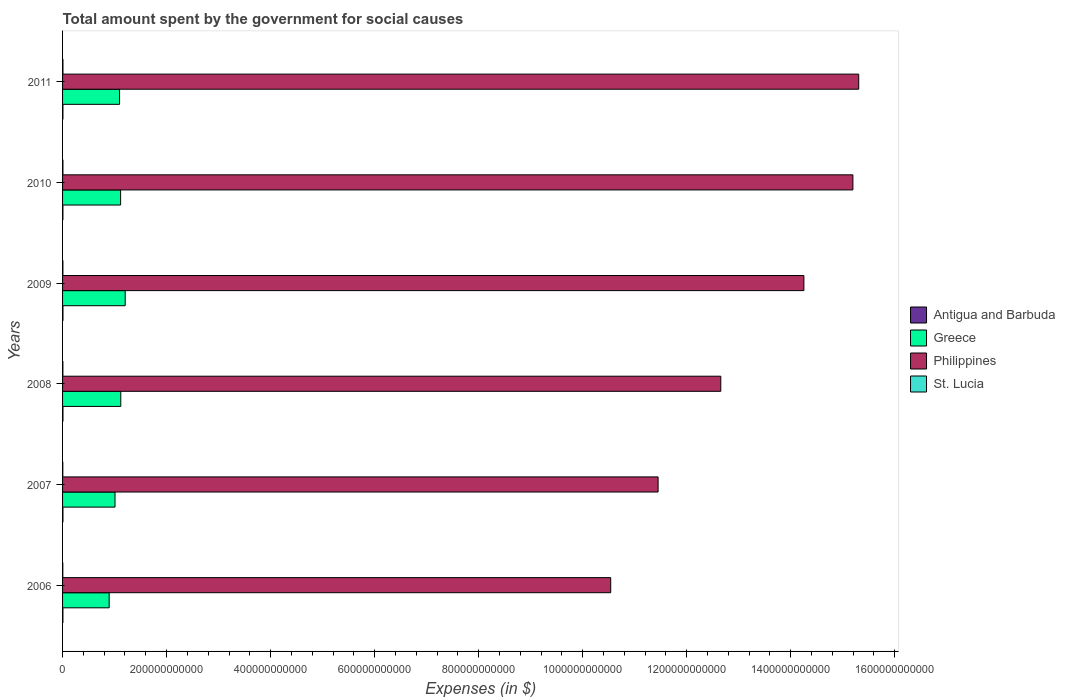How many groups of bars are there?
Ensure brevity in your answer.  6. Are the number of bars per tick equal to the number of legend labels?
Ensure brevity in your answer.  Yes. How many bars are there on the 4th tick from the bottom?
Give a very brief answer. 4. What is the label of the 4th group of bars from the top?
Offer a terse response. 2008. What is the amount spent for social causes by the government in Antigua and Barbuda in 2009?
Your response must be concise. 7.82e+08. Across all years, what is the maximum amount spent for social causes by the government in Greece?
Offer a terse response. 1.20e+11. Across all years, what is the minimum amount spent for social causes by the government in Greece?
Offer a very short reply. 8.96e+1. In which year was the amount spent for social causes by the government in Antigua and Barbuda maximum?
Ensure brevity in your answer.  2009. What is the total amount spent for social causes by the government in Antigua and Barbuda in the graph?
Provide a succinct answer. 4.37e+09. What is the difference between the amount spent for social causes by the government in St. Lucia in 2010 and that in 2011?
Your answer should be compact. -2.20e+07. What is the difference between the amount spent for social causes by the government in Greece in 2006 and the amount spent for social causes by the government in St. Lucia in 2008?
Keep it short and to the point. 8.89e+1. What is the average amount spent for social causes by the government in Greece per year?
Give a very brief answer. 1.07e+11. In the year 2006, what is the difference between the amount spent for social causes by the government in Philippines and amount spent for social causes by the government in St. Lucia?
Give a very brief answer. 1.05e+12. What is the ratio of the amount spent for social causes by the government in Philippines in 2008 to that in 2011?
Your answer should be very brief. 0.83. Is the amount spent for social causes by the government in Antigua and Barbuda in 2009 less than that in 2010?
Ensure brevity in your answer.  No. What is the difference between the highest and the second highest amount spent for social causes by the government in Greece?
Your answer should be compact. 8.50e+09. What is the difference between the highest and the lowest amount spent for social causes by the government in Greece?
Ensure brevity in your answer.  3.09e+1. In how many years, is the amount spent for social causes by the government in Greece greater than the average amount spent for social causes by the government in Greece taken over all years?
Offer a very short reply. 4. Is the sum of the amount spent for social causes by the government in Greece in 2006 and 2011 greater than the maximum amount spent for social causes by the government in Antigua and Barbuda across all years?
Provide a succinct answer. Yes. Is it the case that in every year, the sum of the amount spent for social causes by the government in St. Lucia and amount spent for social causes by the government in Antigua and Barbuda is greater than the sum of amount spent for social causes by the government in Greece and amount spent for social causes by the government in Philippines?
Your answer should be very brief. No. What does the 3rd bar from the top in 2011 represents?
Ensure brevity in your answer.  Greece. Is it the case that in every year, the sum of the amount spent for social causes by the government in St. Lucia and amount spent for social causes by the government in Philippines is greater than the amount spent for social causes by the government in Greece?
Offer a very short reply. Yes. How many years are there in the graph?
Your answer should be very brief. 6. What is the difference between two consecutive major ticks on the X-axis?
Your response must be concise. 2.00e+11. Does the graph contain any zero values?
Offer a terse response. No. How many legend labels are there?
Your response must be concise. 4. How are the legend labels stacked?
Offer a very short reply. Vertical. What is the title of the graph?
Your answer should be compact. Total amount spent by the government for social causes. What is the label or title of the X-axis?
Your answer should be very brief. Expenses (in $). What is the label or title of the Y-axis?
Give a very brief answer. Years. What is the Expenses (in $) in Antigua and Barbuda in 2006?
Give a very brief answer. 6.84e+08. What is the Expenses (in $) of Greece in 2006?
Keep it short and to the point. 8.96e+1. What is the Expenses (in $) of Philippines in 2006?
Give a very brief answer. 1.05e+12. What is the Expenses (in $) of St. Lucia in 2006?
Give a very brief answer. 4.85e+08. What is the Expenses (in $) in Antigua and Barbuda in 2007?
Make the answer very short. 7.50e+08. What is the Expenses (in $) in Greece in 2007?
Provide a short and direct response. 1.01e+11. What is the Expenses (in $) in Philippines in 2007?
Offer a terse response. 1.15e+12. What is the Expenses (in $) of St. Lucia in 2007?
Make the answer very short. 4.82e+08. What is the Expenses (in $) in Antigua and Barbuda in 2008?
Ensure brevity in your answer.  7.66e+08. What is the Expenses (in $) in Greece in 2008?
Offer a very short reply. 1.12e+11. What is the Expenses (in $) in Philippines in 2008?
Make the answer very short. 1.27e+12. What is the Expenses (in $) in St. Lucia in 2008?
Offer a terse response. 6.27e+08. What is the Expenses (in $) in Antigua and Barbuda in 2009?
Your answer should be compact. 7.82e+08. What is the Expenses (in $) of Greece in 2009?
Provide a succinct answer. 1.20e+11. What is the Expenses (in $) of Philippines in 2009?
Ensure brevity in your answer.  1.43e+12. What is the Expenses (in $) of St. Lucia in 2009?
Provide a short and direct response. 6.62e+08. What is the Expenses (in $) of Antigua and Barbuda in 2010?
Provide a succinct answer. 6.76e+08. What is the Expenses (in $) of Greece in 2010?
Keep it short and to the point. 1.12e+11. What is the Expenses (in $) of Philippines in 2010?
Give a very brief answer. 1.52e+12. What is the Expenses (in $) of St. Lucia in 2010?
Your answer should be compact. 7.23e+08. What is the Expenses (in $) in Antigua and Barbuda in 2011?
Your response must be concise. 7.15e+08. What is the Expenses (in $) of Greece in 2011?
Provide a short and direct response. 1.10e+11. What is the Expenses (in $) of Philippines in 2011?
Make the answer very short. 1.53e+12. What is the Expenses (in $) in St. Lucia in 2011?
Give a very brief answer. 7.45e+08. Across all years, what is the maximum Expenses (in $) of Antigua and Barbuda?
Provide a short and direct response. 7.82e+08. Across all years, what is the maximum Expenses (in $) in Greece?
Give a very brief answer. 1.20e+11. Across all years, what is the maximum Expenses (in $) of Philippines?
Your answer should be compact. 1.53e+12. Across all years, what is the maximum Expenses (in $) of St. Lucia?
Ensure brevity in your answer.  7.45e+08. Across all years, what is the minimum Expenses (in $) of Antigua and Barbuda?
Offer a very short reply. 6.76e+08. Across all years, what is the minimum Expenses (in $) in Greece?
Provide a short and direct response. 8.96e+1. Across all years, what is the minimum Expenses (in $) of Philippines?
Make the answer very short. 1.05e+12. Across all years, what is the minimum Expenses (in $) of St. Lucia?
Ensure brevity in your answer.  4.82e+08. What is the total Expenses (in $) in Antigua and Barbuda in the graph?
Your response must be concise. 4.37e+09. What is the total Expenses (in $) of Greece in the graph?
Give a very brief answer. 6.44e+11. What is the total Expenses (in $) of Philippines in the graph?
Provide a succinct answer. 7.94e+12. What is the total Expenses (in $) of St. Lucia in the graph?
Your answer should be compact. 3.72e+09. What is the difference between the Expenses (in $) in Antigua and Barbuda in 2006 and that in 2007?
Your answer should be compact. -6.55e+07. What is the difference between the Expenses (in $) of Greece in 2006 and that in 2007?
Your answer should be compact. -1.13e+1. What is the difference between the Expenses (in $) in Philippines in 2006 and that in 2007?
Provide a succinct answer. -9.11e+1. What is the difference between the Expenses (in $) in St. Lucia in 2006 and that in 2007?
Provide a succinct answer. 2.40e+06. What is the difference between the Expenses (in $) in Antigua and Barbuda in 2006 and that in 2008?
Make the answer very short. -8.22e+07. What is the difference between the Expenses (in $) of Greece in 2006 and that in 2008?
Your response must be concise. -2.24e+1. What is the difference between the Expenses (in $) in Philippines in 2006 and that in 2008?
Make the answer very short. -2.12e+11. What is the difference between the Expenses (in $) of St. Lucia in 2006 and that in 2008?
Offer a terse response. -1.43e+08. What is the difference between the Expenses (in $) of Antigua and Barbuda in 2006 and that in 2009?
Give a very brief answer. -9.76e+07. What is the difference between the Expenses (in $) in Greece in 2006 and that in 2009?
Offer a terse response. -3.09e+1. What is the difference between the Expenses (in $) of Philippines in 2006 and that in 2009?
Your response must be concise. -3.71e+11. What is the difference between the Expenses (in $) of St. Lucia in 2006 and that in 2009?
Give a very brief answer. -1.77e+08. What is the difference between the Expenses (in $) in Antigua and Barbuda in 2006 and that in 2010?
Ensure brevity in your answer.  7.90e+06. What is the difference between the Expenses (in $) in Greece in 2006 and that in 2010?
Offer a very short reply. -2.20e+1. What is the difference between the Expenses (in $) of Philippines in 2006 and that in 2010?
Give a very brief answer. -4.66e+11. What is the difference between the Expenses (in $) of St. Lucia in 2006 and that in 2010?
Keep it short and to the point. -2.38e+08. What is the difference between the Expenses (in $) in Antigua and Barbuda in 2006 and that in 2011?
Make the answer very short. -3.06e+07. What is the difference between the Expenses (in $) of Greece in 2006 and that in 2011?
Offer a very short reply. -2.00e+1. What is the difference between the Expenses (in $) of Philippines in 2006 and that in 2011?
Your answer should be compact. -4.77e+11. What is the difference between the Expenses (in $) of St. Lucia in 2006 and that in 2011?
Ensure brevity in your answer.  -2.60e+08. What is the difference between the Expenses (in $) in Antigua and Barbuda in 2007 and that in 2008?
Keep it short and to the point. -1.67e+07. What is the difference between the Expenses (in $) of Greece in 2007 and that in 2008?
Ensure brevity in your answer.  -1.11e+1. What is the difference between the Expenses (in $) in Philippines in 2007 and that in 2008?
Offer a terse response. -1.21e+11. What is the difference between the Expenses (in $) in St. Lucia in 2007 and that in 2008?
Make the answer very short. -1.45e+08. What is the difference between the Expenses (in $) in Antigua and Barbuda in 2007 and that in 2009?
Provide a short and direct response. -3.21e+07. What is the difference between the Expenses (in $) in Greece in 2007 and that in 2009?
Your response must be concise. -1.96e+1. What is the difference between the Expenses (in $) of Philippines in 2007 and that in 2009?
Your answer should be very brief. -2.80e+11. What is the difference between the Expenses (in $) in St. Lucia in 2007 and that in 2009?
Your answer should be compact. -1.79e+08. What is the difference between the Expenses (in $) in Antigua and Barbuda in 2007 and that in 2010?
Ensure brevity in your answer.  7.34e+07. What is the difference between the Expenses (in $) in Greece in 2007 and that in 2010?
Ensure brevity in your answer.  -1.08e+1. What is the difference between the Expenses (in $) of Philippines in 2007 and that in 2010?
Ensure brevity in your answer.  -3.75e+11. What is the difference between the Expenses (in $) of St. Lucia in 2007 and that in 2010?
Provide a succinct answer. -2.41e+08. What is the difference between the Expenses (in $) in Antigua and Barbuda in 2007 and that in 2011?
Give a very brief answer. 3.49e+07. What is the difference between the Expenses (in $) of Greece in 2007 and that in 2011?
Offer a very short reply. -8.78e+09. What is the difference between the Expenses (in $) in Philippines in 2007 and that in 2011?
Give a very brief answer. -3.86e+11. What is the difference between the Expenses (in $) in St. Lucia in 2007 and that in 2011?
Give a very brief answer. -2.63e+08. What is the difference between the Expenses (in $) of Antigua and Barbuda in 2008 and that in 2009?
Provide a short and direct response. -1.54e+07. What is the difference between the Expenses (in $) of Greece in 2008 and that in 2009?
Your answer should be very brief. -8.50e+09. What is the difference between the Expenses (in $) in Philippines in 2008 and that in 2009?
Your response must be concise. -1.60e+11. What is the difference between the Expenses (in $) of St. Lucia in 2008 and that in 2009?
Provide a short and direct response. -3.44e+07. What is the difference between the Expenses (in $) in Antigua and Barbuda in 2008 and that in 2010?
Provide a short and direct response. 9.01e+07. What is the difference between the Expenses (in $) in Greece in 2008 and that in 2010?
Ensure brevity in your answer.  3.37e+08. What is the difference between the Expenses (in $) in Philippines in 2008 and that in 2010?
Offer a terse response. -2.54e+11. What is the difference between the Expenses (in $) of St. Lucia in 2008 and that in 2010?
Provide a succinct answer. -9.58e+07. What is the difference between the Expenses (in $) of Antigua and Barbuda in 2008 and that in 2011?
Your answer should be very brief. 5.16e+07. What is the difference between the Expenses (in $) of Greece in 2008 and that in 2011?
Provide a short and direct response. 2.32e+09. What is the difference between the Expenses (in $) of Philippines in 2008 and that in 2011?
Offer a terse response. -2.65e+11. What is the difference between the Expenses (in $) of St. Lucia in 2008 and that in 2011?
Keep it short and to the point. -1.18e+08. What is the difference between the Expenses (in $) in Antigua and Barbuda in 2009 and that in 2010?
Your answer should be very brief. 1.06e+08. What is the difference between the Expenses (in $) in Greece in 2009 and that in 2010?
Offer a terse response. 8.84e+09. What is the difference between the Expenses (in $) of Philippines in 2009 and that in 2010?
Give a very brief answer. -9.42e+1. What is the difference between the Expenses (in $) of St. Lucia in 2009 and that in 2010?
Offer a terse response. -6.14e+07. What is the difference between the Expenses (in $) of Antigua and Barbuda in 2009 and that in 2011?
Your answer should be compact. 6.70e+07. What is the difference between the Expenses (in $) of Greece in 2009 and that in 2011?
Make the answer very short. 1.08e+1. What is the difference between the Expenses (in $) of Philippines in 2009 and that in 2011?
Provide a succinct answer. -1.05e+11. What is the difference between the Expenses (in $) in St. Lucia in 2009 and that in 2011?
Make the answer very short. -8.34e+07. What is the difference between the Expenses (in $) of Antigua and Barbuda in 2010 and that in 2011?
Keep it short and to the point. -3.85e+07. What is the difference between the Expenses (in $) of Greece in 2010 and that in 2011?
Offer a very short reply. 1.98e+09. What is the difference between the Expenses (in $) of Philippines in 2010 and that in 2011?
Your response must be concise. -1.12e+1. What is the difference between the Expenses (in $) in St. Lucia in 2010 and that in 2011?
Your response must be concise. -2.20e+07. What is the difference between the Expenses (in $) of Antigua and Barbuda in 2006 and the Expenses (in $) of Greece in 2007?
Make the answer very short. -1.00e+11. What is the difference between the Expenses (in $) in Antigua and Barbuda in 2006 and the Expenses (in $) in Philippines in 2007?
Keep it short and to the point. -1.14e+12. What is the difference between the Expenses (in $) of Antigua and Barbuda in 2006 and the Expenses (in $) of St. Lucia in 2007?
Provide a short and direct response. 2.02e+08. What is the difference between the Expenses (in $) in Greece in 2006 and the Expenses (in $) in Philippines in 2007?
Ensure brevity in your answer.  -1.06e+12. What is the difference between the Expenses (in $) in Greece in 2006 and the Expenses (in $) in St. Lucia in 2007?
Give a very brief answer. 8.91e+1. What is the difference between the Expenses (in $) in Philippines in 2006 and the Expenses (in $) in St. Lucia in 2007?
Your answer should be compact. 1.05e+12. What is the difference between the Expenses (in $) in Antigua and Barbuda in 2006 and the Expenses (in $) in Greece in 2008?
Keep it short and to the point. -1.11e+11. What is the difference between the Expenses (in $) in Antigua and Barbuda in 2006 and the Expenses (in $) in Philippines in 2008?
Make the answer very short. -1.26e+12. What is the difference between the Expenses (in $) of Antigua and Barbuda in 2006 and the Expenses (in $) of St. Lucia in 2008?
Your answer should be compact. 5.67e+07. What is the difference between the Expenses (in $) of Greece in 2006 and the Expenses (in $) of Philippines in 2008?
Your response must be concise. -1.18e+12. What is the difference between the Expenses (in $) in Greece in 2006 and the Expenses (in $) in St. Lucia in 2008?
Your answer should be very brief. 8.89e+1. What is the difference between the Expenses (in $) of Philippines in 2006 and the Expenses (in $) of St. Lucia in 2008?
Give a very brief answer. 1.05e+12. What is the difference between the Expenses (in $) in Antigua and Barbuda in 2006 and the Expenses (in $) in Greece in 2009?
Give a very brief answer. -1.20e+11. What is the difference between the Expenses (in $) in Antigua and Barbuda in 2006 and the Expenses (in $) in Philippines in 2009?
Make the answer very short. -1.42e+12. What is the difference between the Expenses (in $) of Antigua and Barbuda in 2006 and the Expenses (in $) of St. Lucia in 2009?
Provide a succinct answer. 2.23e+07. What is the difference between the Expenses (in $) of Greece in 2006 and the Expenses (in $) of Philippines in 2009?
Ensure brevity in your answer.  -1.34e+12. What is the difference between the Expenses (in $) in Greece in 2006 and the Expenses (in $) in St. Lucia in 2009?
Offer a terse response. 8.89e+1. What is the difference between the Expenses (in $) in Philippines in 2006 and the Expenses (in $) in St. Lucia in 2009?
Ensure brevity in your answer.  1.05e+12. What is the difference between the Expenses (in $) of Antigua and Barbuda in 2006 and the Expenses (in $) of Greece in 2010?
Keep it short and to the point. -1.11e+11. What is the difference between the Expenses (in $) of Antigua and Barbuda in 2006 and the Expenses (in $) of Philippines in 2010?
Give a very brief answer. -1.52e+12. What is the difference between the Expenses (in $) of Antigua and Barbuda in 2006 and the Expenses (in $) of St. Lucia in 2010?
Your answer should be compact. -3.91e+07. What is the difference between the Expenses (in $) of Greece in 2006 and the Expenses (in $) of Philippines in 2010?
Your response must be concise. -1.43e+12. What is the difference between the Expenses (in $) in Greece in 2006 and the Expenses (in $) in St. Lucia in 2010?
Offer a terse response. 8.88e+1. What is the difference between the Expenses (in $) of Philippines in 2006 and the Expenses (in $) of St. Lucia in 2010?
Keep it short and to the point. 1.05e+12. What is the difference between the Expenses (in $) of Antigua and Barbuda in 2006 and the Expenses (in $) of Greece in 2011?
Provide a succinct answer. -1.09e+11. What is the difference between the Expenses (in $) of Antigua and Barbuda in 2006 and the Expenses (in $) of Philippines in 2011?
Your answer should be very brief. -1.53e+12. What is the difference between the Expenses (in $) in Antigua and Barbuda in 2006 and the Expenses (in $) in St. Lucia in 2011?
Ensure brevity in your answer.  -6.11e+07. What is the difference between the Expenses (in $) of Greece in 2006 and the Expenses (in $) of Philippines in 2011?
Provide a short and direct response. -1.44e+12. What is the difference between the Expenses (in $) of Greece in 2006 and the Expenses (in $) of St. Lucia in 2011?
Give a very brief answer. 8.88e+1. What is the difference between the Expenses (in $) of Philippines in 2006 and the Expenses (in $) of St. Lucia in 2011?
Provide a short and direct response. 1.05e+12. What is the difference between the Expenses (in $) of Antigua and Barbuda in 2007 and the Expenses (in $) of Greece in 2008?
Your answer should be compact. -1.11e+11. What is the difference between the Expenses (in $) in Antigua and Barbuda in 2007 and the Expenses (in $) in Philippines in 2008?
Your answer should be compact. -1.26e+12. What is the difference between the Expenses (in $) of Antigua and Barbuda in 2007 and the Expenses (in $) of St. Lucia in 2008?
Ensure brevity in your answer.  1.22e+08. What is the difference between the Expenses (in $) in Greece in 2007 and the Expenses (in $) in Philippines in 2008?
Keep it short and to the point. -1.16e+12. What is the difference between the Expenses (in $) of Greece in 2007 and the Expenses (in $) of St. Lucia in 2008?
Provide a succinct answer. 1.00e+11. What is the difference between the Expenses (in $) of Philippines in 2007 and the Expenses (in $) of St. Lucia in 2008?
Give a very brief answer. 1.14e+12. What is the difference between the Expenses (in $) in Antigua and Barbuda in 2007 and the Expenses (in $) in Greece in 2009?
Keep it short and to the point. -1.20e+11. What is the difference between the Expenses (in $) in Antigua and Barbuda in 2007 and the Expenses (in $) in Philippines in 2009?
Your answer should be compact. -1.42e+12. What is the difference between the Expenses (in $) in Antigua and Barbuda in 2007 and the Expenses (in $) in St. Lucia in 2009?
Offer a terse response. 8.78e+07. What is the difference between the Expenses (in $) of Greece in 2007 and the Expenses (in $) of Philippines in 2009?
Your answer should be compact. -1.32e+12. What is the difference between the Expenses (in $) in Greece in 2007 and the Expenses (in $) in St. Lucia in 2009?
Offer a terse response. 1.00e+11. What is the difference between the Expenses (in $) of Philippines in 2007 and the Expenses (in $) of St. Lucia in 2009?
Provide a short and direct response. 1.14e+12. What is the difference between the Expenses (in $) in Antigua and Barbuda in 2007 and the Expenses (in $) in Greece in 2010?
Provide a succinct answer. -1.11e+11. What is the difference between the Expenses (in $) of Antigua and Barbuda in 2007 and the Expenses (in $) of Philippines in 2010?
Your response must be concise. -1.52e+12. What is the difference between the Expenses (in $) of Antigua and Barbuda in 2007 and the Expenses (in $) of St. Lucia in 2010?
Your response must be concise. 2.64e+07. What is the difference between the Expenses (in $) in Greece in 2007 and the Expenses (in $) in Philippines in 2010?
Provide a succinct answer. -1.42e+12. What is the difference between the Expenses (in $) in Greece in 2007 and the Expenses (in $) in St. Lucia in 2010?
Your answer should be very brief. 1.00e+11. What is the difference between the Expenses (in $) in Philippines in 2007 and the Expenses (in $) in St. Lucia in 2010?
Provide a succinct answer. 1.14e+12. What is the difference between the Expenses (in $) of Antigua and Barbuda in 2007 and the Expenses (in $) of Greece in 2011?
Offer a terse response. -1.09e+11. What is the difference between the Expenses (in $) of Antigua and Barbuda in 2007 and the Expenses (in $) of Philippines in 2011?
Offer a very short reply. -1.53e+12. What is the difference between the Expenses (in $) in Antigua and Barbuda in 2007 and the Expenses (in $) in St. Lucia in 2011?
Ensure brevity in your answer.  4.40e+06. What is the difference between the Expenses (in $) of Greece in 2007 and the Expenses (in $) of Philippines in 2011?
Provide a short and direct response. -1.43e+12. What is the difference between the Expenses (in $) of Greece in 2007 and the Expenses (in $) of St. Lucia in 2011?
Your answer should be very brief. 1.00e+11. What is the difference between the Expenses (in $) in Philippines in 2007 and the Expenses (in $) in St. Lucia in 2011?
Your response must be concise. 1.14e+12. What is the difference between the Expenses (in $) in Antigua and Barbuda in 2008 and the Expenses (in $) in Greece in 2009?
Your answer should be very brief. -1.20e+11. What is the difference between the Expenses (in $) in Antigua and Barbuda in 2008 and the Expenses (in $) in Philippines in 2009?
Offer a very short reply. -1.42e+12. What is the difference between the Expenses (in $) in Antigua and Barbuda in 2008 and the Expenses (in $) in St. Lucia in 2009?
Your response must be concise. 1.04e+08. What is the difference between the Expenses (in $) in Greece in 2008 and the Expenses (in $) in Philippines in 2009?
Offer a very short reply. -1.31e+12. What is the difference between the Expenses (in $) of Greece in 2008 and the Expenses (in $) of St. Lucia in 2009?
Offer a very short reply. 1.11e+11. What is the difference between the Expenses (in $) of Philippines in 2008 and the Expenses (in $) of St. Lucia in 2009?
Keep it short and to the point. 1.26e+12. What is the difference between the Expenses (in $) in Antigua and Barbuda in 2008 and the Expenses (in $) in Greece in 2010?
Offer a very short reply. -1.11e+11. What is the difference between the Expenses (in $) in Antigua and Barbuda in 2008 and the Expenses (in $) in Philippines in 2010?
Offer a terse response. -1.52e+12. What is the difference between the Expenses (in $) in Antigua and Barbuda in 2008 and the Expenses (in $) in St. Lucia in 2010?
Make the answer very short. 4.31e+07. What is the difference between the Expenses (in $) in Greece in 2008 and the Expenses (in $) in Philippines in 2010?
Offer a terse response. -1.41e+12. What is the difference between the Expenses (in $) of Greece in 2008 and the Expenses (in $) of St. Lucia in 2010?
Offer a terse response. 1.11e+11. What is the difference between the Expenses (in $) of Philippines in 2008 and the Expenses (in $) of St. Lucia in 2010?
Provide a succinct answer. 1.26e+12. What is the difference between the Expenses (in $) in Antigua and Barbuda in 2008 and the Expenses (in $) in Greece in 2011?
Offer a terse response. -1.09e+11. What is the difference between the Expenses (in $) of Antigua and Barbuda in 2008 and the Expenses (in $) of Philippines in 2011?
Provide a short and direct response. -1.53e+12. What is the difference between the Expenses (in $) of Antigua and Barbuda in 2008 and the Expenses (in $) of St. Lucia in 2011?
Your answer should be very brief. 2.11e+07. What is the difference between the Expenses (in $) of Greece in 2008 and the Expenses (in $) of Philippines in 2011?
Your answer should be compact. -1.42e+12. What is the difference between the Expenses (in $) of Greece in 2008 and the Expenses (in $) of St. Lucia in 2011?
Offer a very short reply. 1.11e+11. What is the difference between the Expenses (in $) of Philippines in 2008 and the Expenses (in $) of St. Lucia in 2011?
Give a very brief answer. 1.26e+12. What is the difference between the Expenses (in $) of Antigua and Barbuda in 2009 and the Expenses (in $) of Greece in 2010?
Keep it short and to the point. -1.11e+11. What is the difference between the Expenses (in $) in Antigua and Barbuda in 2009 and the Expenses (in $) in Philippines in 2010?
Your answer should be compact. -1.52e+12. What is the difference between the Expenses (in $) of Antigua and Barbuda in 2009 and the Expenses (in $) of St. Lucia in 2010?
Offer a very short reply. 5.85e+07. What is the difference between the Expenses (in $) in Greece in 2009 and the Expenses (in $) in Philippines in 2010?
Provide a succinct answer. -1.40e+12. What is the difference between the Expenses (in $) in Greece in 2009 and the Expenses (in $) in St. Lucia in 2010?
Your answer should be very brief. 1.20e+11. What is the difference between the Expenses (in $) of Philippines in 2009 and the Expenses (in $) of St. Lucia in 2010?
Your response must be concise. 1.42e+12. What is the difference between the Expenses (in $) of Antigua and Barbuda in 2009 and the Expenses (in $) of Greece in 2011?
Your answer should be very brief. -1.09e+11. What is the difference between the Expenses (in $) of Antigua and Barbuda in 2009 and the Expenses (in $) of Philippines in 2011?
Keep it short and to the point. -1.53e+12. What is the difference between the Expenses (in $) of Antigua and Barbuda in 2009 and the Expenses (in $) of St. Lucia in 2011?
Offer a terse response. 3.65e+07. What is the difference between the Expenses (in $) in Greece in 2009 and the Expenses (in $) in Philippines in 2011?
Give a very brief answer. -1.41e+12. What is the difference between the Expenses (in $) of Greece in 2009 and the Expenses (in $) of St. Lucia in 2011?
Your response must be concise. 1.20e+11. What is the difference between the Expenses (in $) in Philippines in 2009 and the Expenses (in $) in St. Lucia in 2011?
Offer a very short reply. 1.42e+12. What is the difference between the Expenses (in $) of Antigua and Barbuda in 2010 and the Expenses (in $) of Greece in 2011?
Give a very brief answer. -1.09e+11. What is the difference between the Expenses (in $) of Antigua and Barbuda in 2010 and the Expenses (in $) of Philippines in 2011?
Ensure brevity in your answer.  -1.53e+12. What is the difference between the Expenses (in $) in Antigua and Barbuda in 2010 and the Expenses (in $) in St. Lucia in 2011?
Offer a very short reply. -6.90e+07. What is the difference between the Expenses (in $) in Greece in 2010 and the Expenses (in $) in Philippines in 2011?
Provide a short and direct response. -1.42e+12. What is the difference between the Expenses (in $) of Greece in 2010 and the Expenses (in $) of St. Lucia in 2011?
Offer a very short reply. 1.11e+11. What is the difference between the Expenses (in $) of Philippines in 2010 and the Expenses (in $) of St. Lucia in 2011?
Keep it short and to the point. 1.52e+12. What is the average Expenses (in $) in Antigua and Barbuda per year?
Give a very brief answer. 7.29e+08. What is the average Expenses (in $) of Greece per year?
Offer a terse response. 1.07e+11. What is the average Expenses (in $) of Philippines per year?
Keep it short and to the point. 1.32e+12. What is the average Expenses (in $) of St. Lucia per year?
Offer a terse response. 6.21e+08. In the year 2006, what is the difference between the Expenses (in $) in Antigua and Barbuda and Expenses (in $) in Greece?
Your answer should be compact. -8.89e+1. In the year 2006, what is the difference between the Expenses (in $) in Antigua and Barbuda and Expenses (in $) in Philippines?
Offer a terse response. -1.05e+12. In the year 2006, what is the difference between the Expenses (in $) of Antigua and Barbuda and Expenses (in $) of St. Lucia?
Offer a terse response. 1.99e+08. In the year 2006, what is the difference between the Expenses (in $) of Greece and Expenses (in $) of Philippines?
Offer a very short reply. -9.64e+11. In the year 2006, what is the difference between the Expenses (in $) of Greece and Expenses (in $) of St. Lucia?
Give a very brief answer. 8.91e+1. In the year 2006, what is the difference between the Expenses (in $) of Philippines and Expenses (in $) of St. Lucia?
Offer a terse response. 1.05e+12. In the year 2007, what is the difference between the Expenses (in $) in Antigua and Barbuda and Expenses (in $) in Greece?
Give a very brief answer. -1.00e+11. In the year 2007, what is the difference between the Expenses (in $) in Antigua and Barbuda and Expenses (in $) in Philippines?
Offer a terse response. -1.14e+12. In the year 2007, what is the difference between the Expenses (in $) in Antigua and Barbuda and Expenses (in $) in St. Lucia?
Provide a short and direct response. 2.67e+08. In the year 2007, what is the difference between the Expenses (in $) in Greece and Expenses (in $) in Philippines?
Keep it short and to the point. -1.04e+12. In the year 2007, what is the difference between the Expenses (in $) in Greece and Expenses (in $) in St. Lucia?
Your answer should be compact. 1.00e+11. In the year 2007, what is the difference between the Expenses (in $) in Philippines and Expenses (in $) in St. Lucia?
Make the answer very short. 1.14e+12. In the year 2008, what is the difference between the Expenses (in $) in Antigua and Barbuda and Expenses (in $) in Greece?
Keep it short and to the point. -1.11e+11. In the year 2008, what is the difference between the Expenses (in $) in Antigua and Barbuda and Expenses (in $) in Philippines?
Your response must be concise. -1.26e+12. In the year 2008, what is the difference between the Expenses (in $) of Antigua and Barbuda and Expenses (in $) of St. Lucia?
Offer a terse response. 1.39e+08. In the year 2008, what is the difference between the Expenses (in $) in Greece and Expenses (in $) in Philippines?
Ensure brevity in your answer.  -1.15e+12. In the year 2008, what is the difference between the Expenses (in $) in Greece and Expenses (in $) in St. Lucia?
Keep it short and to the point. 1.11e+11. In the year 2008, what is the difference between the Expenses (in $) of Philippines and Expenses (in $) of St. Lucia?
Make the answer very short. 1.26e+12. In the year 2009, what is the difference between the Expenses (in $) of Antigua and Barbuda and Expenses (in $) of Greece?
Keep it short and to the point. -1.20e+11. In the year 2009, what is the difference between the Expenses (in $) of Antigua and Barbuda and Expenses (in $) of Philippines?
Your response must be concise. -1.42e+12. In the year 2009, what is the difference between the Expenses (in $) of Antigua and Barbuda and Expenses (in $) of St. Lucia?
Offer a terse response. 1.20e+08. In the year 2009, what is the difference between the Expenses (in $) of Greece and Expenses (in $) of Philippines?
Give a very brief answer. -1.30e+12. In the year 2009, what is the difference between the Expenses (in $) of Greece and Expenses (in $) of St. Lucia?
Offer a very short reply. 1.20e+11. In the year 2009, what is the difference between the Expenses (in $) of Philippines and Expenses (in $) of St. Lucia?
Give a very brief answer. 1.42e+12. In the year 2010, what is the difference between the Expenses (in $) in Antigua and Barbuda and Expenses (in $) in Greece?
Provide a short and direct response. -1.11e+11. In the year 2010, what is the difference between the Expenses (in $) of Antigua and Barbuda and Expenses (in $) of Philippines?
Make the answer very short. -1.52e+12. In the year 2010, what is the difference between the Expenses (in $) in Antigua and Barbuda and Expenses (in $) in St. Lucia?
Keep it short and to the point. -4.70e+07. In the year 2010, what is the difference between the Expenses (in $) in Greece and Expenses (in $) in Philippines?
Make the answer very short. -1.41e+12. In the year 2010, what is the difference between the Expenses (in $) of Greece and Expenses (in $) of St. Lucia?
Give a very brief answer. 1.11e+11. In the year 2010, what is the difference between the Expenses (in $) of Philippines and Expenses (in $) of St. Lucia?
Your answer should be very brief. 1.52e+12. In the year 2011, what is the difference between the Expenses (in $) in Antigua and Barbuda and Expenses (in $) in Greece?
Give a very brief answer. -1.09e+11. In the year 2011, what is the difference between the Expenses (in $) of Antigua and Barbuda and Expenses (in $) of Philippines?
Keep it short and to the point. -1.53e+12. In the year 2011, what is the difference between the Expenses (in $) of Antigua and Barbuda and Expenses (in $) of St. Lucia?
Offer a very short reply. -3.05e+07. In the year 2011, what is the difference between the Expenses (in $) of Greece and Expenses (in $) of Philippines?
Keep it short and to the point. -1.42e+12. In the year 2011, what is the difference between the Expenses (in $) in Greece and Expenses (in $) in St. Lucia?
Ensure brevity in your answer.  1.09e+11. In the year 2011, what is the difference between the Expenses (in $) of Philippines and Expenses (in $) of St. Lucia?
Give a very brief answer. 1.53e+12. What is the ratio of the Expenses (in $) of Antigua and Barbuda in 2006 to that in 2007?
Your answer should be very brief. 0.91. What is the ratio of the Expenses (in $) in Greece in 2006 to that in 2007?
Ensure brevity in your answer.  0.89. What is the ratio of the Expenses (in $) of Philippines in 2006 to that in 2007?
Give a very brief answer. 0.92. What is the ratio of the Expenses (in $) in Antigua and Barbuda in 2006 to that in 2008?
Your answer should be very brief. 0.89. What is the ratio of the Expenses (in $) in Greece in 2006 to that in 2008?
Your answer should be compact. 0.8. What is the ratio of the Expenses (in $) of Philippines in 2006 to that in 2008?
Make the answer very short. 0.83. What is the ratio of the Expenses (in $) in St. Lucia in 2006 to that in 2008?
Give a very brief answer. 0.77. What is the ratio of the Expenses (in $) in Antigua and Barbuda in 2006 to that in 2009?
Keep it short and to the point. 0.88. What is the ratio of the Expenses (in $) of Greece in 2006 to that in 2009?
Make the answer very short. 0.74. What is the ratio of the Expenses (in $) in Philippines in 2006 to that in 2009?
Give a very brief answer. 0.74. What is the ratio of the Expenses (in $) of St. Lucia in 2006 to that in 2009?
Offer a very short reply. 0.73. What is the ratio of the Expenses (in $) in Antigua and Barbuda in 2006 to that in 2010?
Keep it short and to the point. 1.01. What is the ratio of the Expenses (in $) of Greece in 2006 to that in 2010?
Keep it short and to the point. 0.8. What is the ratio of the Expenses (in $) in Philippines in 2006 to that in 2010?
Your answer should be very brief. 0.69. What is the ratio of the Expenses (in $) in St. Lucia in 2006 to that in 2010?
Your answer should be very brief. 0.67. What is the ratio of the Expenses (in $) of Antigua and Barbuda in 2006 to that in 2011?
Your answer should be very brief. 0.96. What is the ratio of the Expenses (in $) in Greece in 2006 to that in 2011?
Make the answer very short. 0.82. What is the ratio of the Expenses (in $) in Philippines in 2006 to that in 2011?
Your answer should be very brief. 0.69. What is the ratio of the Expenses (in $) in St. Lucia in 2006 to that in 2011?
Offer a very short reply. 0.65. What is the ratio of the Expenses (in $) of Antigua and Barbuda in 2007 to that in 2008?
Provide a succinct answer. 0.98. What is the ratio of the Expenses (in $) of Greece in 2007 to that in 2008?
Your response must be concise. 0.9. What is the ratio of the Expenses (in $) in Philippines in 2007 to that in 2008?
Give a very brief answer. 0.9. What is the ratio of the Expenses (in $) in St. Lucia in 2007 to that in 2008?
Your answer should be compact. 0.77. What is the ratio of the Expenses (in $) in Antigua and Barbuda in 2007 to that in 2009?
Offer a terse response. 0.96. What is the ratio of the Expenses (in $) of Greece in 2007 to that in 2009?
Give a very brief answer. 0.84. What is the ratio of the Expenses (in $) of Philippines in 2007 to that in 2009?
Provide a short and direct response. 0.8. What is the ratio of the Expenses (in $) in St. Lucia in 2007 to that in 2009?
Your response must be concise. 0.73. What is the ratio of the Expenses (in $) of Antigua and Barbuda in 2007 to that in 2010?
Your answer should be compact. 1.11. What is the ratio of the Expenses (in $) in Greece in 2007 to that in 2010?
Provide a short and direct response. 0.9. What is the ratio of the Expenses (in $) in Philippines in 2007 to that in 2010?
Ensure brevity in your answer.  0.75. What is the ratio of the Expenses (in $) of St. Lucia in 2007 to that in 2010?
Your answer should be very brief. 0.67. What is the ratio of the Expenses (in $) in Antigua and Barbuda in 2007 to that in 2011?
Give a very brief answer. 1.05. What is the ratio of the Expenses (in $) in Greece in 2007 to that in 2011?
Keep it short and to the point. 0.92. What is the ratio of the Expenses (in $) in Philippines in 2007 to that in 2011?
Offer a very short reply. 0.75. What is the ratio of the Expenses (in $) of St. Lucia in 2007 to that in 2011?
Provide a short and direct response. 0.65. What is the ratio of the Expenses (in $) in Antigua and Barbuda in 2008 to that in 2009?
Ensure brevity in your answer.  0.98. What is the ratio of the Expenses (in $) in Greece in 2008 to that in 2009?
Keep it short and to the point. 0.93. What is the ratio of the Expenses (in $) in Philippines in 2008 to that in 2009?
Your answer should be compact. 0.89. What is the ratio of the Expenses (in $) in St. Lucia in 2008 to that in 2009?
Provide a succinct answer. 0.95. What is the ratio of the Expenses (in $) in Antigua and Barbuda in 2008 to that in 2010?
Provide a succinct answer. 1.13. What is the ratio of the Expenses (in $) of Philippines in 2008 to that in 2010?
Keep it short and to the point. 0.83. What is the ratio of the Expenses (in $) in St. Lucia in 2008 to that in 2010?
Provide a short and direct response. 0.87. What is the ratio of the Expenses (in $) in Antigua and Barbuda in 2008 to that in 2011?
Keep it short and to the point. 1.07. What is the ratio of the Expenses (in $) of Greece in 2008 to that in 2011?
Offer a very short reply. 1.02. What is the ratio of the Expenses (in $) in Philippines in 2008 to that in 2011?
Make the answer very short. 0.83. What is the ratio of the Expenses (in $) of St. Lucia in 2008 to that in 2011?
Offer a very short reply. 0.84. What is the ratio of the Expenses (in $) in Antigua and Barbuda in 2009 to that in 2010?
Give a very brief answer. 1.16. What is the ratio of the Expenses (in $) in Greece in 2009 to that in 2010?
Offer a terse response. 1.08. What is the ratio of the Expenses (in $) of Philippines in 2009 to that in 2010?
Your answer should be compact. 0.94. What is the ratio of the Expenses (in $) of St. Lucia in 2009 to that in 2010?
Give a very brief answer. 0.92. What is the ratio of the Expenses (in $) of Antigua and Barbuda in 2009 to that in 2011?
Provide a succinct answer. 1.09. What is the ratio of the Expenses (in $) of Greece in 2009 to that in 2011?
Keep it short and to the point. 1.1. What is the ratio of the Expenses (in $) in Philippines in 2009 to that in 2011?
Give a very brief answer. 0.93. What is the ratio of the Expenses (in $) in St. Lucia in 2009 to that in 2011?
Provide a short and direct response. 0.89. What is the ratio of the Expenses (in $) in Antigua and Barbuda in 2010 to that in 2011?
Keep it short and to the point. 0.95. What is the ratio of the Expenses (in $) in Greece in 2010 to that in 2011?
Offer a very short reply. 1.02. What is the ratio of the Expenses (in $) of Philippines in 2010 to that in 2011?
Ensure brevity in your answer.  0.99. What is the ratio of the Expenses (in $) in St. Lucia in 2010 to that in 2011?
Make the answer very short. 0.97. What is the difference between the highest and the second highest Expenses (in $) of Antigua and Barbuda?
Ensure brevity in your answer.  1.54e+07. What is the difference between the highest and the second highest Expenses (in $) of Greece?
Make the answer very short. 8.50e+09. What is the difference between the highest and the second highest Expenses (in $) in Philippines?
Offer a terse response. 1.12e+1. What is the difference between the highest and the second highest Expenses (in $) in St. Lucia?
Provide a short and direct response. 2.20e+07. What is the difference between the highest and the lowest Expenses (in $) in Antigua and Barbuda?
Offer a terse response. 1.06e+08. What is the difference between the highest and the lowest Expenses (in $) in Greece?
Give a very brief answer. 3.09e+1. What is the difference between the highest and the lowest Expenses (in $) in Philippines?
Your response must be concise. 4.77e+11. What is the difference between the highest and the lowest Expenses (in $) of St. Lucia?
Provide a succinct answer. 2.63e+08. 